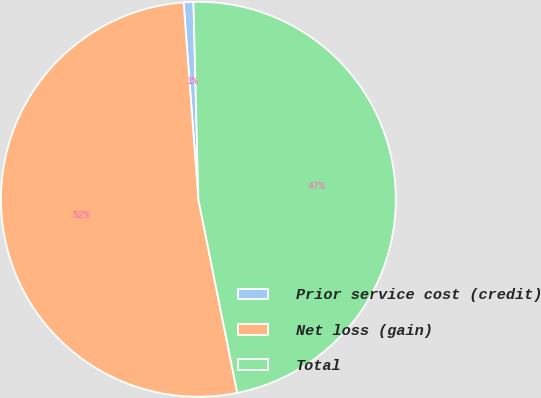<chart> <loc_0><loc_0><loc_500><loc_500><pie_chart><fcel>Prior service cost (credit)<fcel>Net loss (gain)<fcel>Total<nl><fcel>0.8%<fcel>51.96%<fcel>47.24%<nl></chart> 